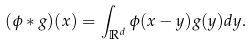Convert formula to latex. <formula><loc_0><loc_0><loc_500><loc_500>( \phi \ast g ) ( x ) = \int _ { \mathbb { R } ^ { d } } \phi ( x - y ) g ( y ) d y .</formula> 